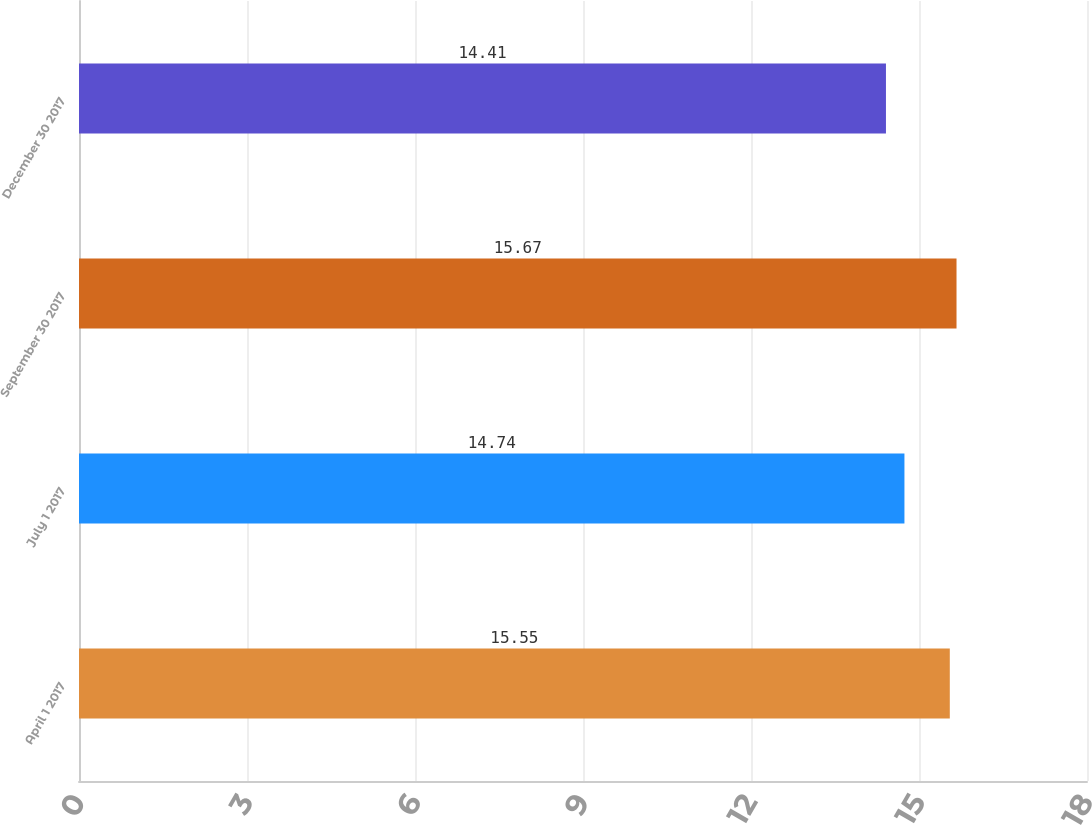Convert chart to OTSL. <chart><loc_0><loc_0><loc_500><loc_500><bar_chart><fcel>April 1 2017<fcel>July 1 2017<fcel>September 30 2017<fcel>December 30 2017<nl><fcel>15.55<fcel>14.74<fcel>15.67<fcel>14.41<nl></chart> 